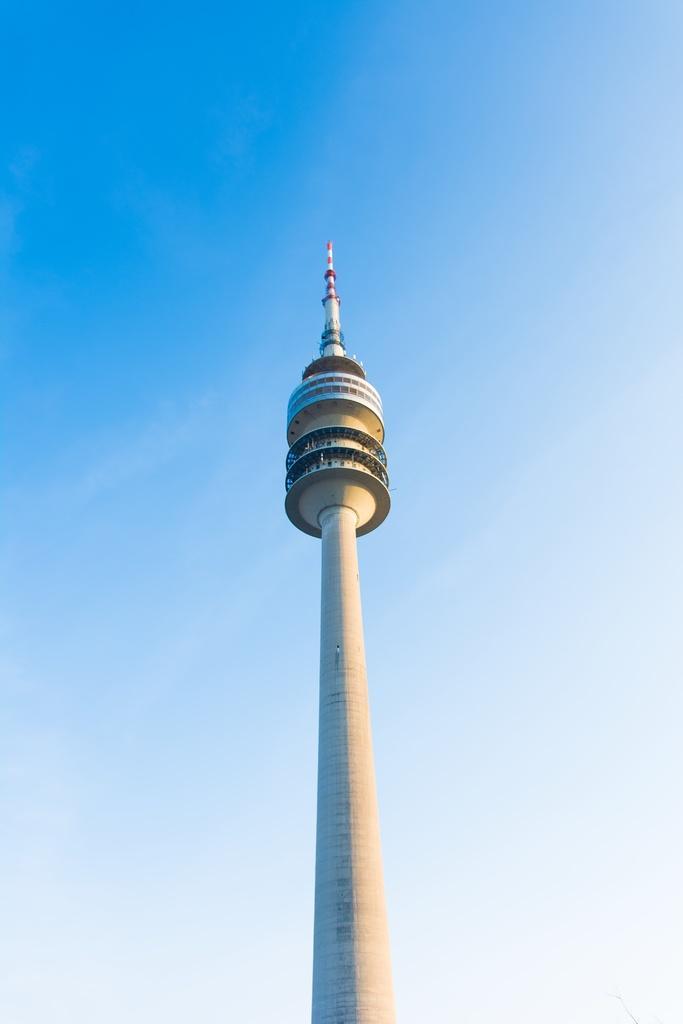In one or two sentences, can you explain what this image depicts? In the center of the image there is a tower. In the background of the image there is sky. 